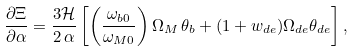<formula> <loc_0><loc_0><loc_500><loc_500>\frac { \partial \Xi } { \partial \alpha } = \frac { 3 { \mathcal { H } } } { 2 \, \alpha } \left [ \left ( \frac { \omega _ { b 0 } } { \omega _ { M 0 } } \right ) \Omega _ { M } \, \theta _ { b } + ( 1 + w _ { d e } ) \Omega _ { d e } \theta _ { d e } \right ] ,</formula> 